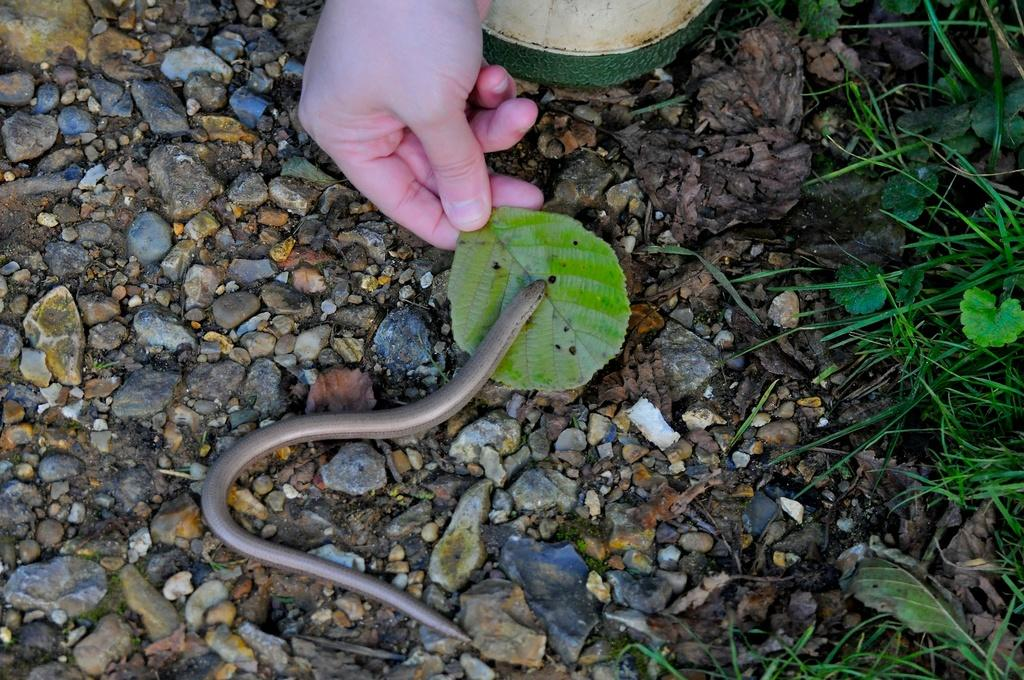What is being held in the image? There is a leaf being held in the image. What type of animal can be seen in the image? There is a snake in the image. What type of vegetation is present in the image? There are plants in the image. What type of inanimate objects can be seen in the image? There are stones in the image. What type of nerve can be seen in the image? There is no nerve present in the image. What type of worm can be seen in the image? There is no worm present in the image. What type of circle can be seen in the image? There is no circle present in the image. 